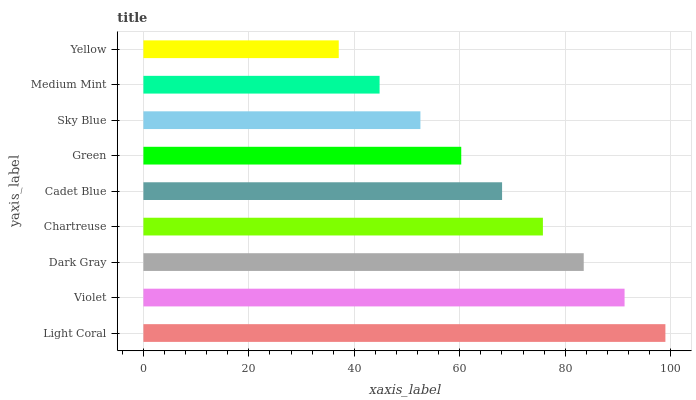Is Yellow the minimum?
Answer yes or no. Yes. Is Light Coral the maximum?
Answer yes or no. Yes. Is Violet the minimum?
Answer yes or no. No. Is Violet the maximum?
Answer yes or no. No. Is Light Coral greater than Violet?
Answer yes or no. Yes. Is Violet less than Light Coral?
Answer yes or no. Yes. Is Violet greater than Light Coral?
Answer yes or no. No. Is Light Coral less than Violet?
Answer yes or no. No. Is Cadet Blue the high median?
Answer yes or no. Yes. Is Cadet Blue the low median?
Answer yes or no. Yes. Is Violet the high median?
Answer yes or no. No. Is Violet the low median?
Answer yes or no. No. 